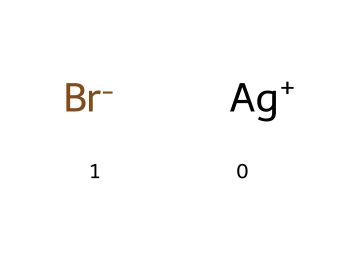What are the components of this chemical? The chemical consists of silver ions (Ag+) and bromide ions (Br-), which are the two distinct species depicted in the SMILES representation.
Answer: silver and bromide How many atoms are present in this molecule? The SMILES shows one silver atom (Ag) and one bromine atom (Br), making a total of two atoms.
Answer: two What is the charge of the silver ion in this chemical? The SMILES indicates that the silver ion is represented as Ag+, which indicates it has a positive charge.
Answer: positive What type of reaction is associated with silver halides? Silver halides typically undergo photodissociation upon exposure to light, which is a common reaction for photoreactive chemicals.
Answer: photodissociation Why are silver halides useful in photosensitive coatings? Silver halides are used in photosensitive coatings due to their ability to undergo photochemical reactions, allowing them to change properties when exposed to light, which is essential for creating images or patterns.
Answer: photochemical reactions Can this molecule function as a photosensitizer? Yes, the structure indicates that it can absorb light and initiate a photochemical reaction, characteristic of photosensitizers.
Answer: yes 